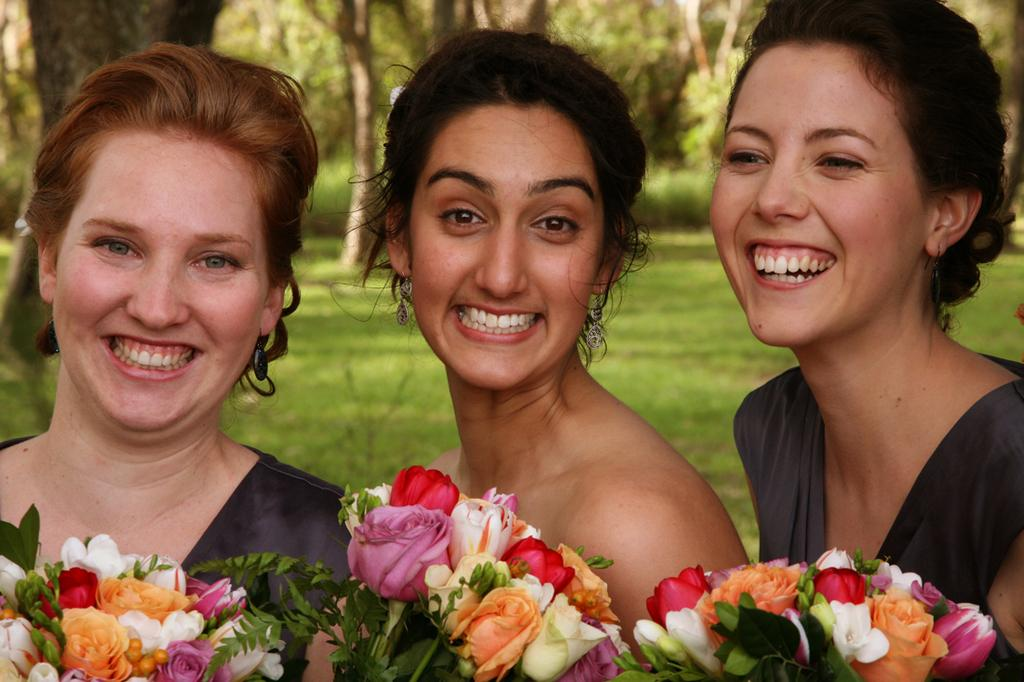How many people are in the image? There are three ladies in the image. What are the ladies doing in the image? The ladies are smiling and holding bouquets. What can be seen in the background of the image? There are trees and grass in the background of the image. What type of sugar is being used to sweeten the recess in the image? There is no sugar or recess present in the image. What is the back of the ladies doing in the image? The ladies are facing forward, so there is no specific action or detail related to their backs in the image. 